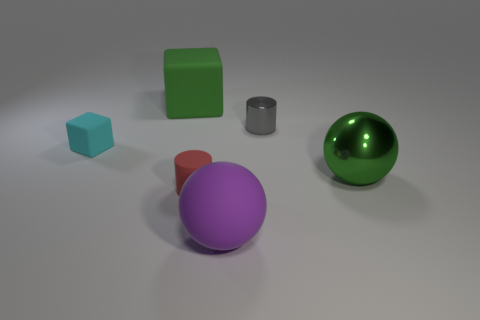Is the number of things behind the large purple rubber thing greater than the number of large green rubber cubes?
Give a very brief answer. Yes. Are the cyan block and the large purple object made of the same material?
Your answer should be compact. Yes. What number of things are big things in front of the small matte cylinder or small things?
Your answer should be compact. 4. How many other objects are the same size as the red matte thing?
Provide a short and direct response. 2. Is the number of tiny gray things that are in front of the tiny gray cylinder the same as the number of blocks in front of the green matte thing?
Keep it short and to the point. No. The other thing that is the same shape as the tiny red object is what color?
Your response must be concise. Gray. Do the big rubber thing left of the big purple ball and the large metal sphere have the same color?
Offer a very short reply. Yes. There is a gray thing that is the same shape as the small red thing; what size is it?
Your response must be concise. Small. How many green objects have the same material as the red cylinder?
Offer a terse response. 1. Are there any large rubber things in front of the big green thing on the left side of the small cylinder that is behind the cyan matte block?
Give a very brief answer. Yes. 